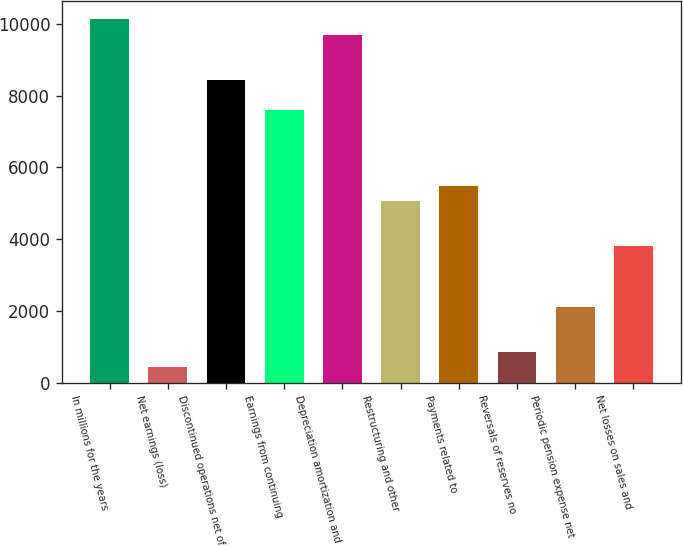Convert chart to OTSL. <chart><loc_0><loc_0><loc_500><loc_500><bar_chart><fcel>In millions for the years<fcel>Net earnings (loss)<fcel>Discontinued operations net of<fcel>Earnings from continuing<fcel>Depreciation amortization and<fcel>Restructuring and other<fcel>Payments related to<fcel>Reversals of reserves no<fcel>Periodic pension expense net<fcel>Net losses on sales and<nl><fcel>10120<fcel>425.5<fcel>8434<fcel>7591<fcel>9698.5<fcel>5062<fcel>5483.5<fcel>847<fcel>2111.5<fcel>3797.5<nl></chart> 